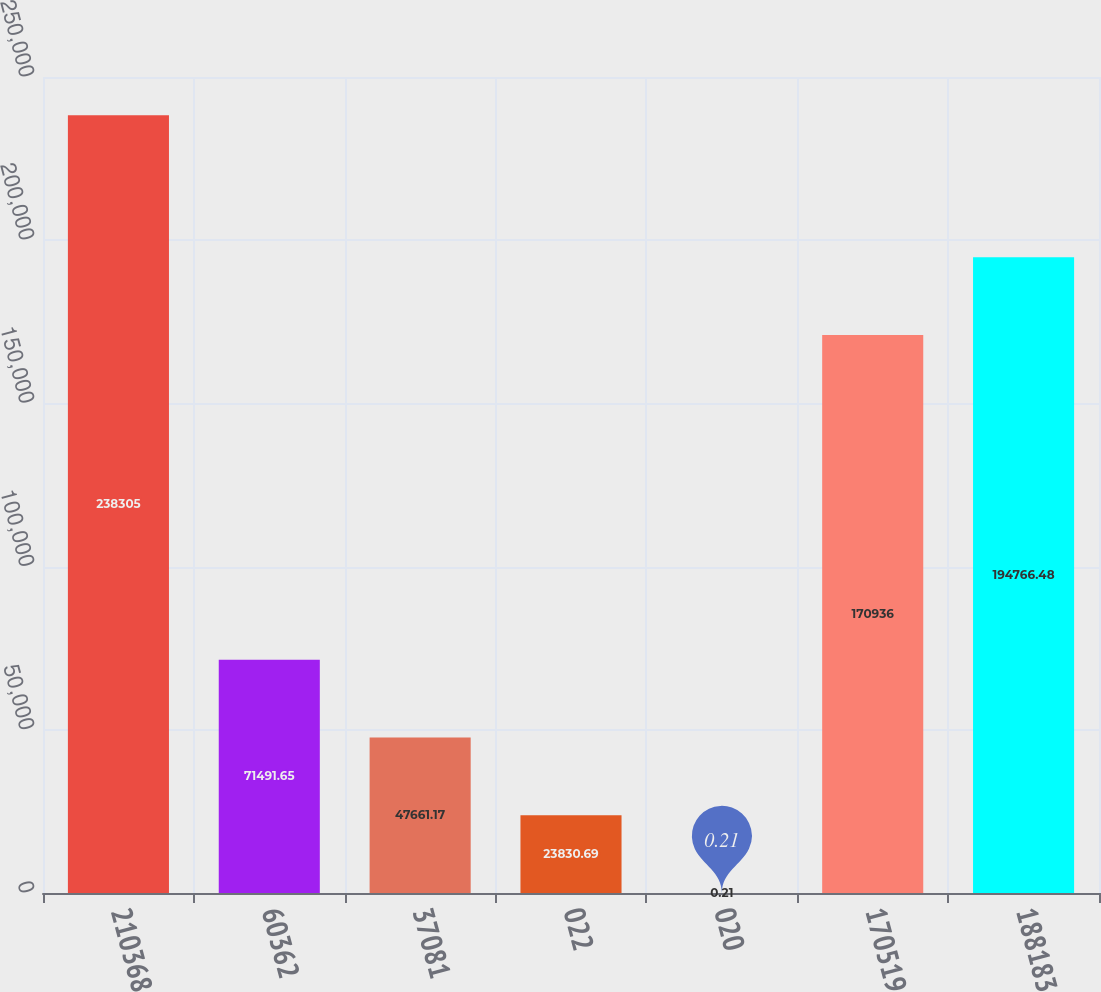Convert chart. <chart><loc_0><loc_0><loc_500><loc_500><bar_chart><fcel>210368<fcel>60362<fcel>37081<fcel>022<fcel>020<fcel>170519<fcel>188183<nl><fcel>238305<fcel>71491.6<fcel>47661.2<fcel>23830.7<fcel>0.21<fcel>170936<fcel>194766<nl></chart> 